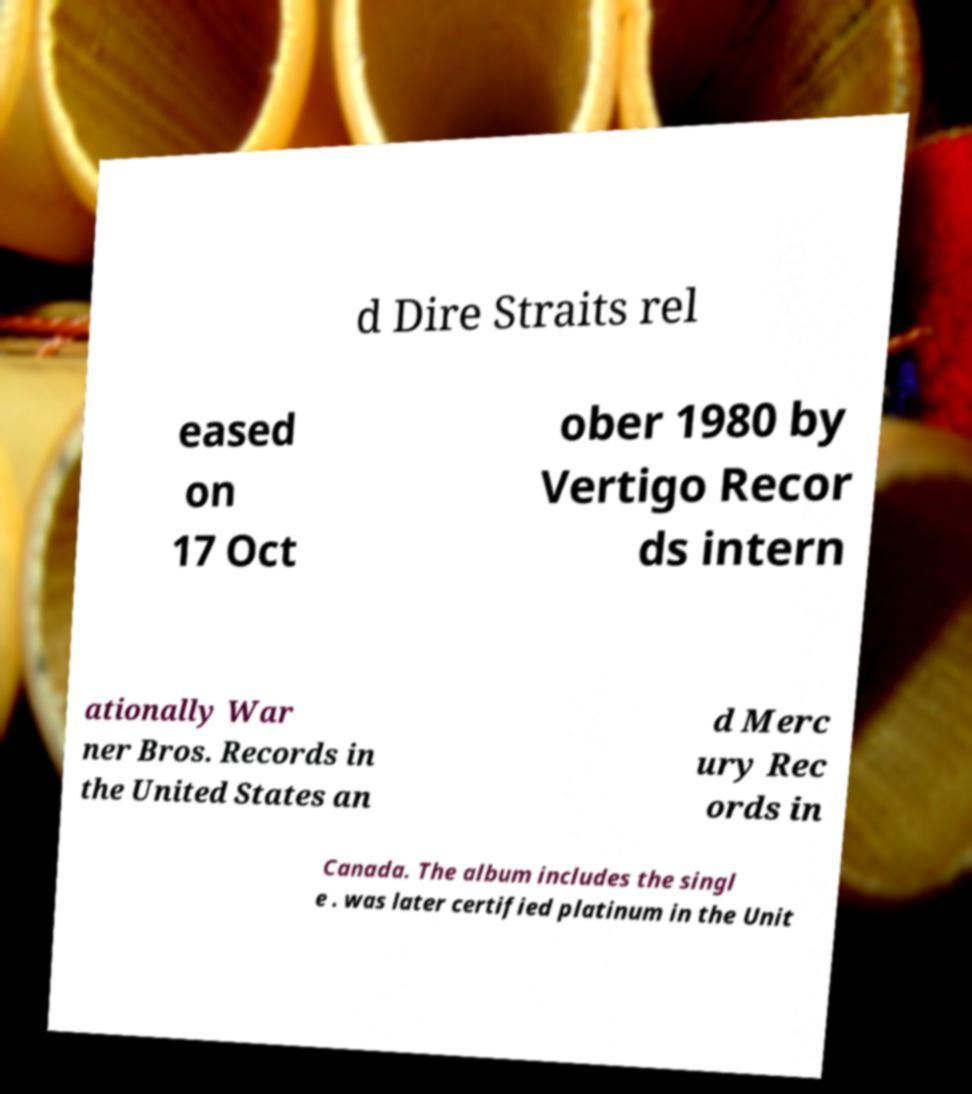Please read and relay the text visible in this image. What does it say? d Dire Straits rel eased on 17 Oct ober 1980 by Vertigo Recor ds intern ationally War ner Bros. Records in the United States an d Merc ury Rec ords in Canada. The album includes the singl e . was later certified platinum in the Unit 